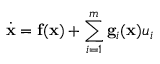Convert formula to latex. <formula><loc_0><loc_0><loc_500><loc_500>{ \dot { x } } = f ( x ) + \sum _ { i = 1 } ^ { m } g _ { i } ( x ) u _ { i }</formula> 